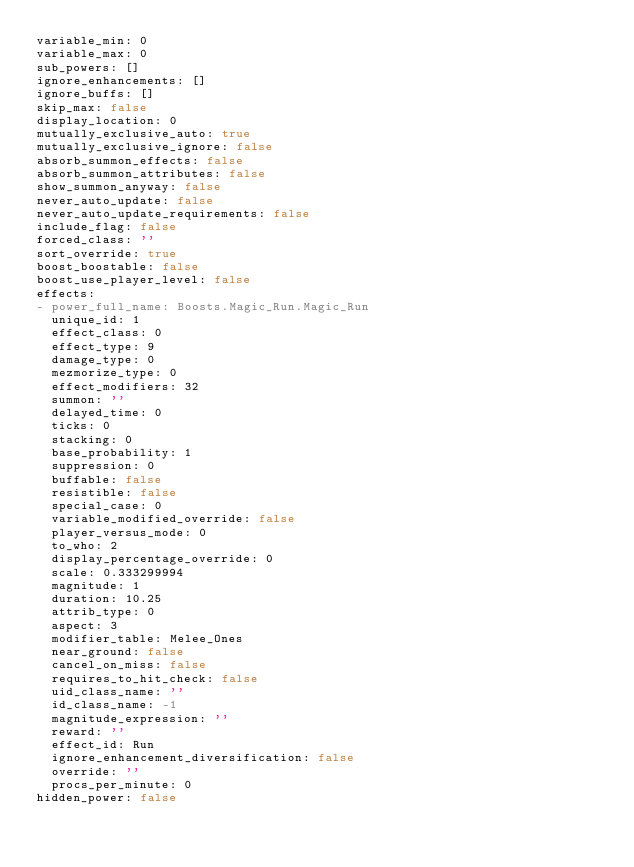Convert code to text. <code><loc_0><loc_0><loc_500><loc_500><_YAML_>variable_min: 0
variable_max: 0
sub_powers: []
ignore_enhancements: []
ignore_buffs: []
skip_max: false
display_location: 0
mutually_exclusive_auto: true
mutually_exclusive_ignore: false
absorb_summon_effects: false
absorb_summon_attributes: false
show_summon_anyway: false
never_auto_update: false
never_auto_update_requirements: false
include_flag: false
forced_class: ''
sort_override: true
boost_boostable: false
boost_use_player_level: false
effects:
- power_full_name: Boosts.Magic_Run.Magic_Run
  unique_id: 1
  effect_class: 0
  effect_type: 9
  damage_type: 0
  mezmorize_type: 0
  effect_modifiers: 32
  summon: ''
  delayed_time: 0
  ticks: 0
  stacking: 0
  base_probability: 1
  suppression: 0
  buffable: false
  resistible: false
  special_case: 0
  variable_modified_override: false
  player_versus_mode: 0
  to_who: 2
  display_percentage_override: 0
  scale: 0.333299994
  magnitude: 1
  duration: 10.25
  attrib_type: 0
  aspect: 3
  modifier_table: Melee_Ones
  near_ground: false
  cancel_on_miss: false
  requires_to_hit_check: false
  uid_class_name: ''
  id_class_name: -1
  magnitude_expression: ''
  reward: ''
  effect_id: Run
  ignore_enhancement_diversification: false
  override: ''
  procs_per_minute: 0
hidden_power: false
</code> 